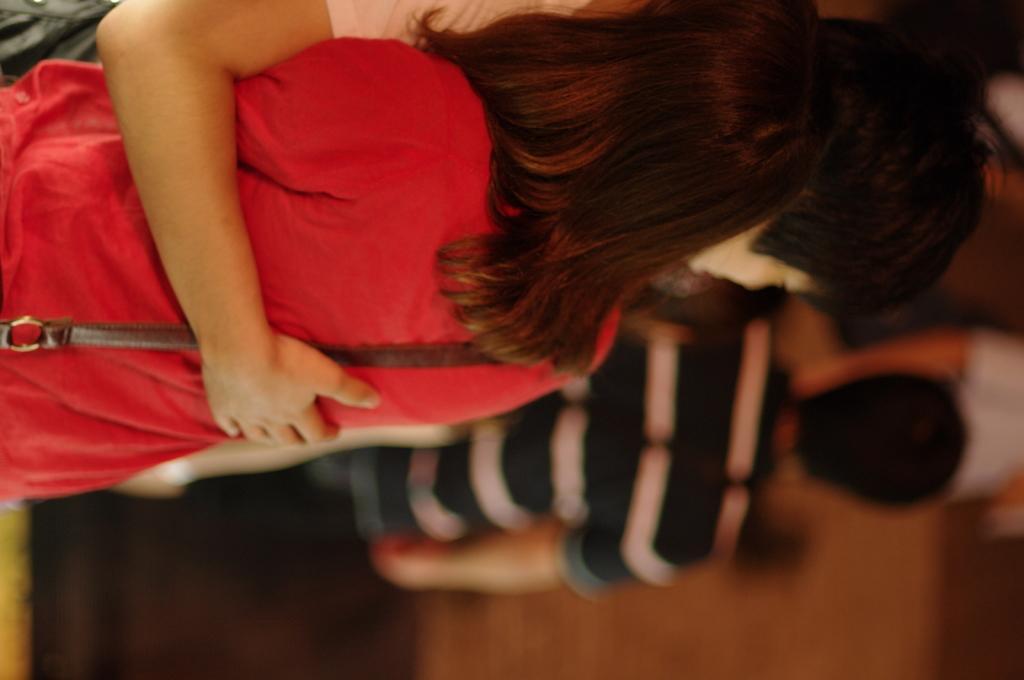Describe this image in one or two sentences. There are two people standing and holding each other. In the background we can see people and it is blurry. 